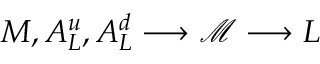Convert formula to latex. <formula><loc_0><loc_0><loc_500><loc_500>M , A _ { L } ^ { u } , A _ { L } ^ { d } \longrightarrow \mathcal { M } \longrightarrow L</formula> 